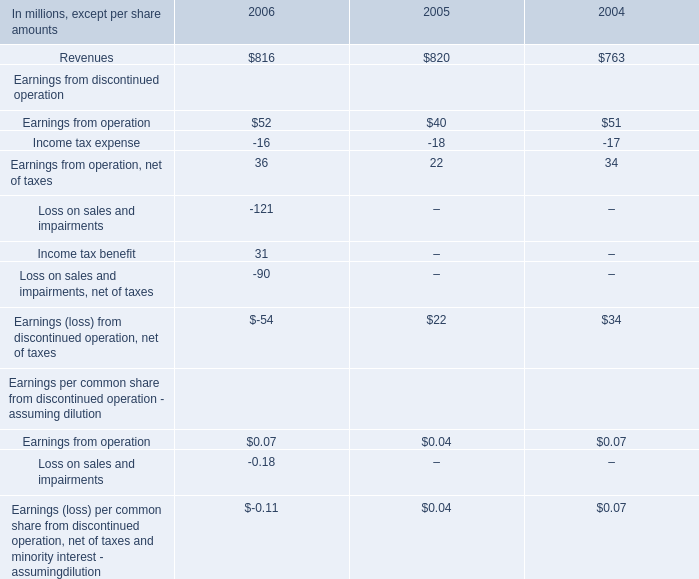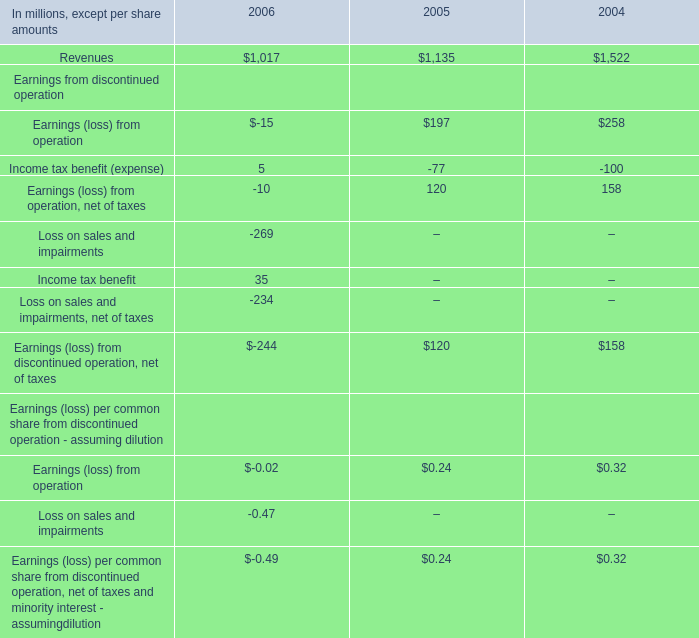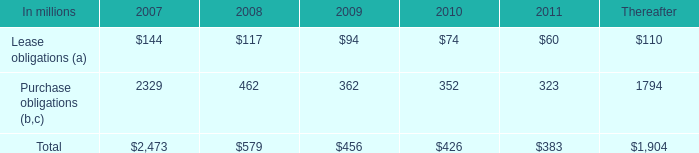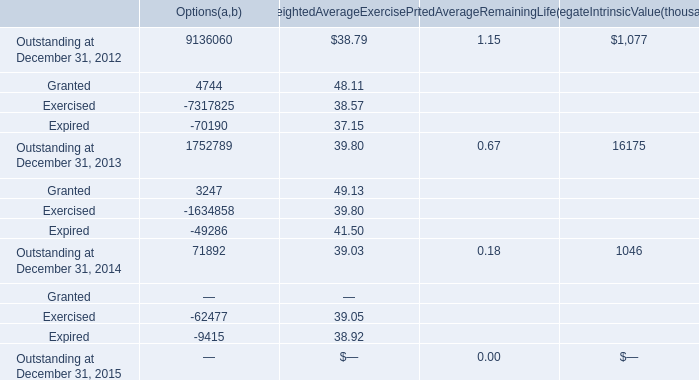In what year is Weighted Average Exercise Price for Outstanding on December 31 greater than 39.50? 
Answer: 2013. 